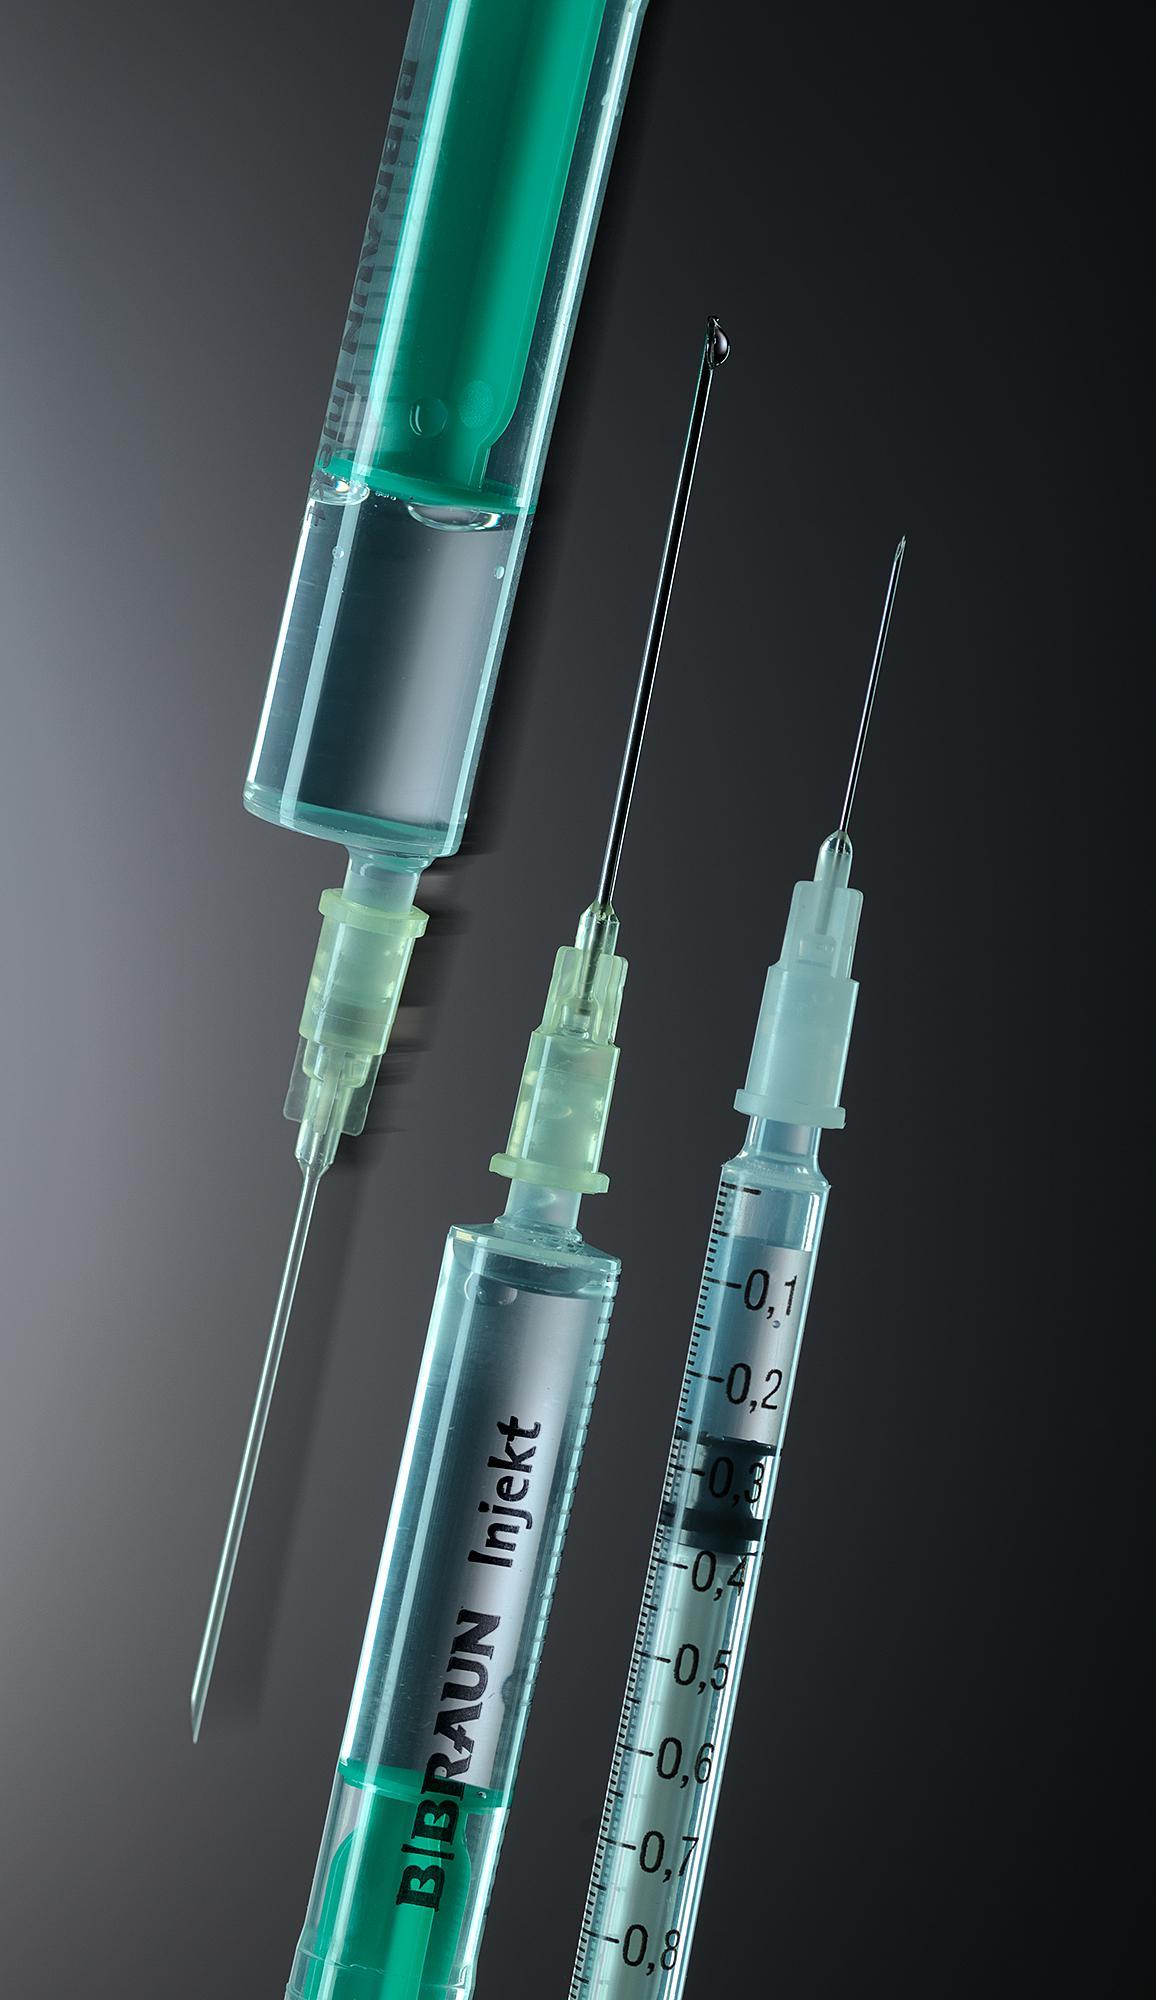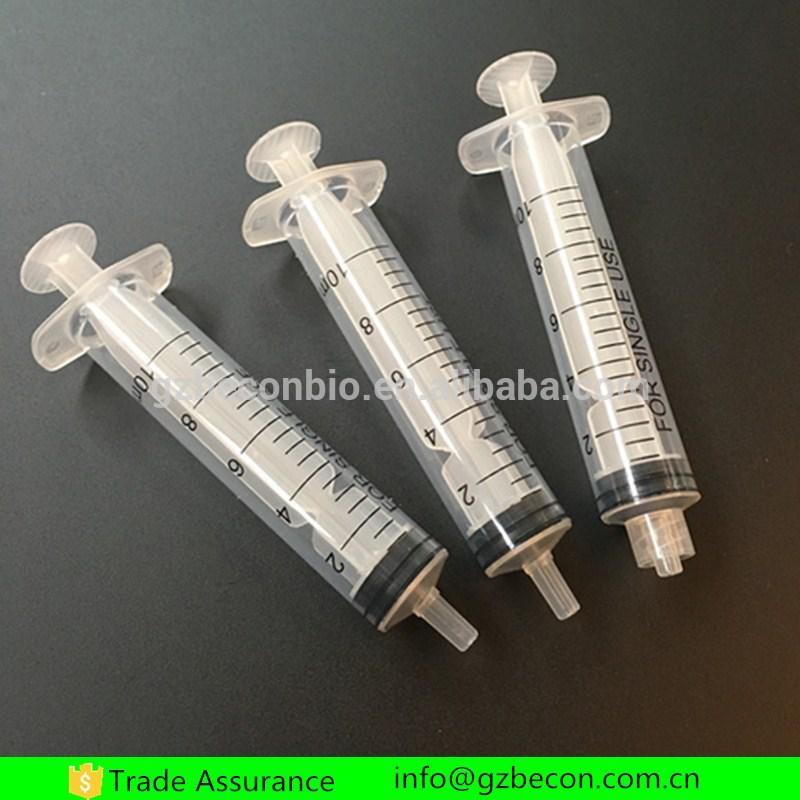The first image is the image on the left, the second image is the image on the right. Examine the images to the left and right. Is the description "The right image has three syringes." accurate? Answer yes or no. Yes. The first image is the image on the left, the second image is the image on the right. Evaluate the accuracy of this statement regarding the images: "Each image shows exactly three syringe-related items.". Is it true? Answer yes or no. Yes. 